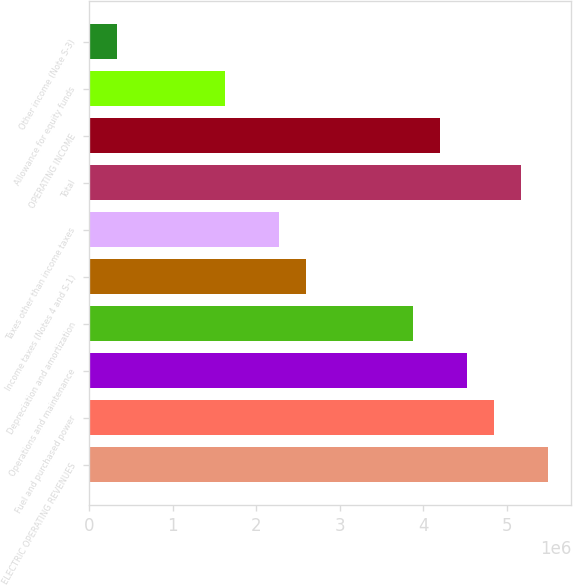Convert chart. <chart><loc_0><loc_0><loc_500><loc_500><bar_chart><fcel>ELECTRIC OPERATING REVENUES<fcel>Fuel and purchased power<fcel>Operations and maintenance<fcel>Depreciation and amortization<fcel>Income taxes (Notes 4 and S-1)<fcel>Taxes other than income taxes<fcel>Total<fcel>OPERATING INCOME<fcel>Allowance for equity funds<fcel>Other income (Note S-3)<nl><fcel>5.50008e+06<fcel>4.85355e+06<fcel>4.53029e+06<fcel>3.88377e+06<fcel>2.59072e+06<fcel>2.26745e+06<fcel>5.17682e+06<fcel>4.20703e+06<fcel>1.62093e+06<fcel>327878<nl></chart> 